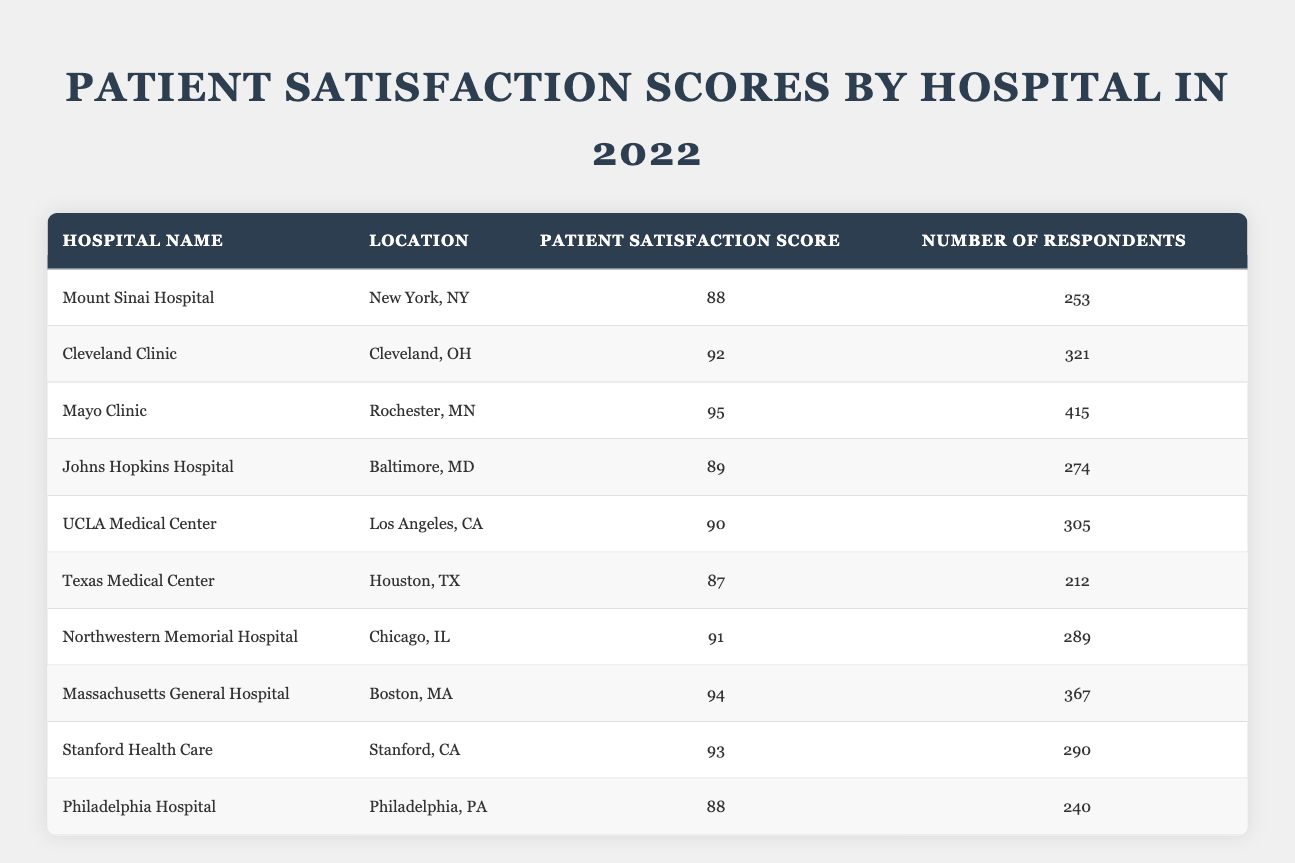What is the Patient Satisfaction Score for Mayo Clinic? The table shows that Mayo Clinic has a Patient Satisfaction Score listed in the third column as 95.
Answer: 95 Which hospital has the highest Patient Satisfaction Score? By reviewing the scores in the third column, Mayo Clinic has the highest score of 95 compared to others.
Answer: Mayo Clinic What is the average Patient Satisfaction Score of all hospitals listed? To find the average, add the scores (88 + 92 + 95 + 89 + 90 + 87 + 91 + 94 + 93 + 88) which equals 909. There are 10 hospitals, so the average is 909/10 = 90.9.
Answer: 90.9 How many respondents did Johns Hopkins Hospital have? Looking at the fourth column for Johns Hopkins Hospital, the number of respondents is 274.
Answer: 274 Is the Patient Satisfaction Score for Texas Medical Center above 90? The score for Texas Medical Center is 87, which is below 90, so the answer is no.
Answer: No What is the difference in Patient Satisfaction Scores between the highest and lowest rated hospitals? The highest score is Mayo Clinic's 95 and the lowest is Texas Medical Center's 87. The difference is 95 - 87 = 8.
Answer: 8 How many hospitals had a Patient Satisfaction Score of 90 or above? The hospitals with scores of 90 or above are Cleveland Clinic (92), Mayo Clinic (95), Northwestern Memorial Hospital (91), Massachusetts General Hospital (94), Stanford Health Care (93), and UCLA Medical Center (90), which totals 6 hospitals.
Answer: 6 What is the total number of respondents across all hospitals? By summing the number of respondents (253 + 321 + 415 + 274 + 305 + 212 + 289 + 367 + 290 + 240), the total comes to 2,787 respondents.
Answer: 2787 Which hospital located in California has a better Patient Satisfaction Score: UCLA Medical Center or Stanford Health Care? UCLA Medical Center has a score of 90 and Stanford Health Care has a score of 93. Since 93 is higher than 90, Stanford Health Care is better.
Answer: Stanford Health Care Are there more hospitals with scores above or below 90? The hospitals with scores above 90 are Cleveland Clinic, Mayo Clinic, Northwestern Memorial Hospital, Massachusetts General Hospital, Stanford Health Care, and UCLA Medical Center (total 6). The hospitals below 90 are Mount Sinai Hospital, Johns Hopkins Hospital, Texas Medical Center, and Philadelphia Hospital (total 4). Since 6 is greater than 4, there are more hospitals above 90.
Answer: Yes, more hospitals have scores above 90 